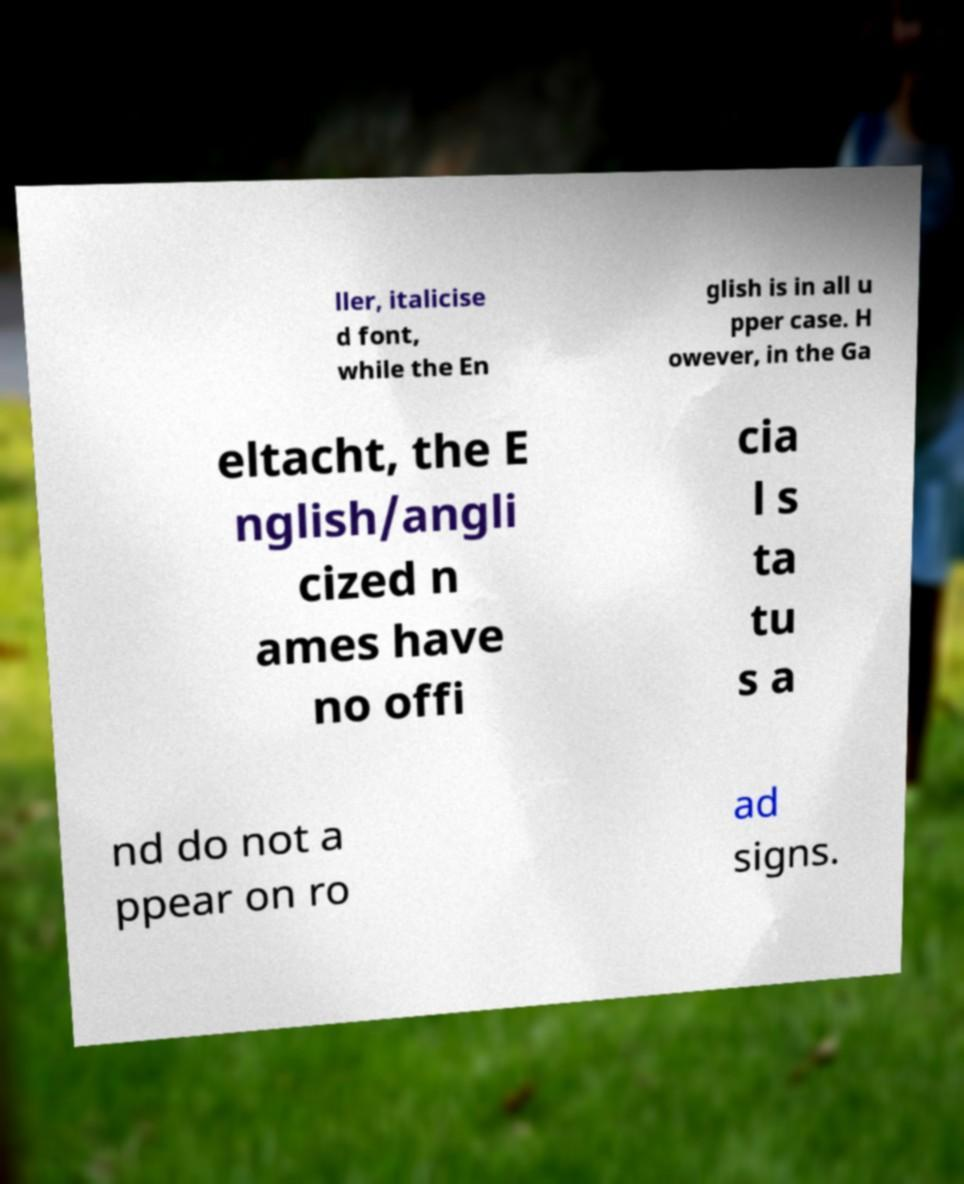Please read and relay the text visible in this image. What does it say? ller, italicise d font, while the En glish is in all u pper case. H owever, in the Ga eltacht, the E nglish/angli cized n ames have no offi cia l s ta tu s a nd do not a ppear on ro ad signs. 